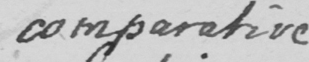Please provide the text content of this handwritten line. comparative 